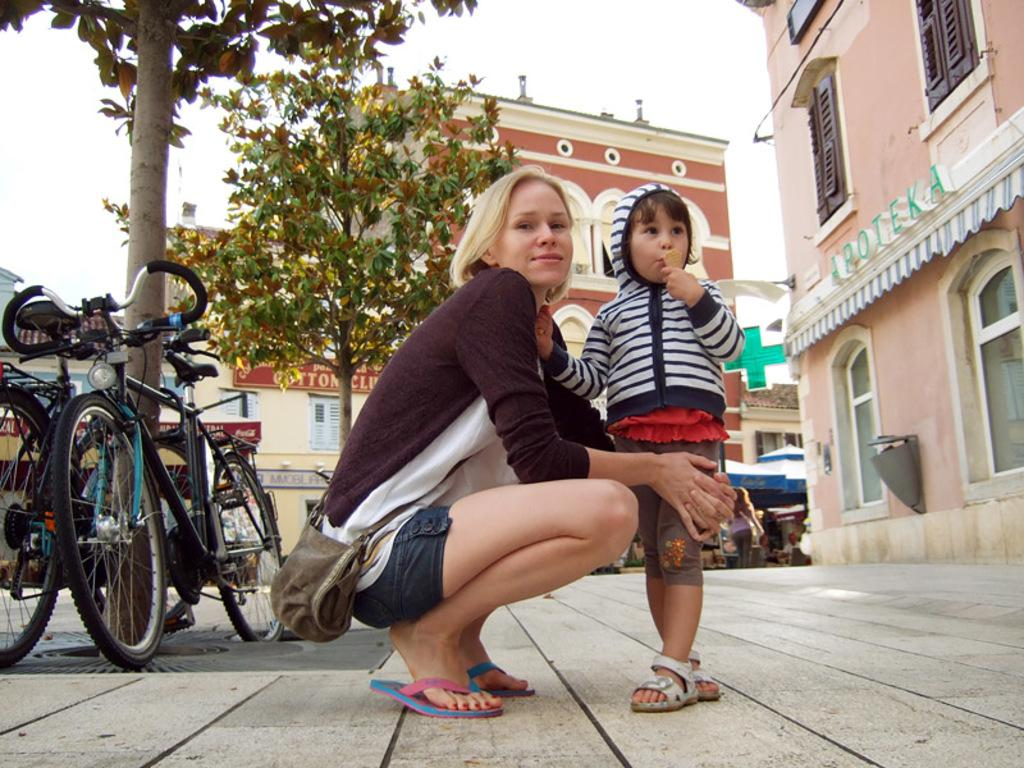Who is present in the image? There is a woman and a kid in the image. What objects can be seen in the image? Bicycles are present in the image. What type of natural elements can be seen in the image? There are trees in the image. What type of man-made structures can be seen in the image? There are buildings in the image. What is visible in the background of the image? The sky is visible in the image. How much money is the woman holding in the image? There is no money visible in the image; it only shows a woman, a kid, bicycles, trees, buildings, and the sky. 